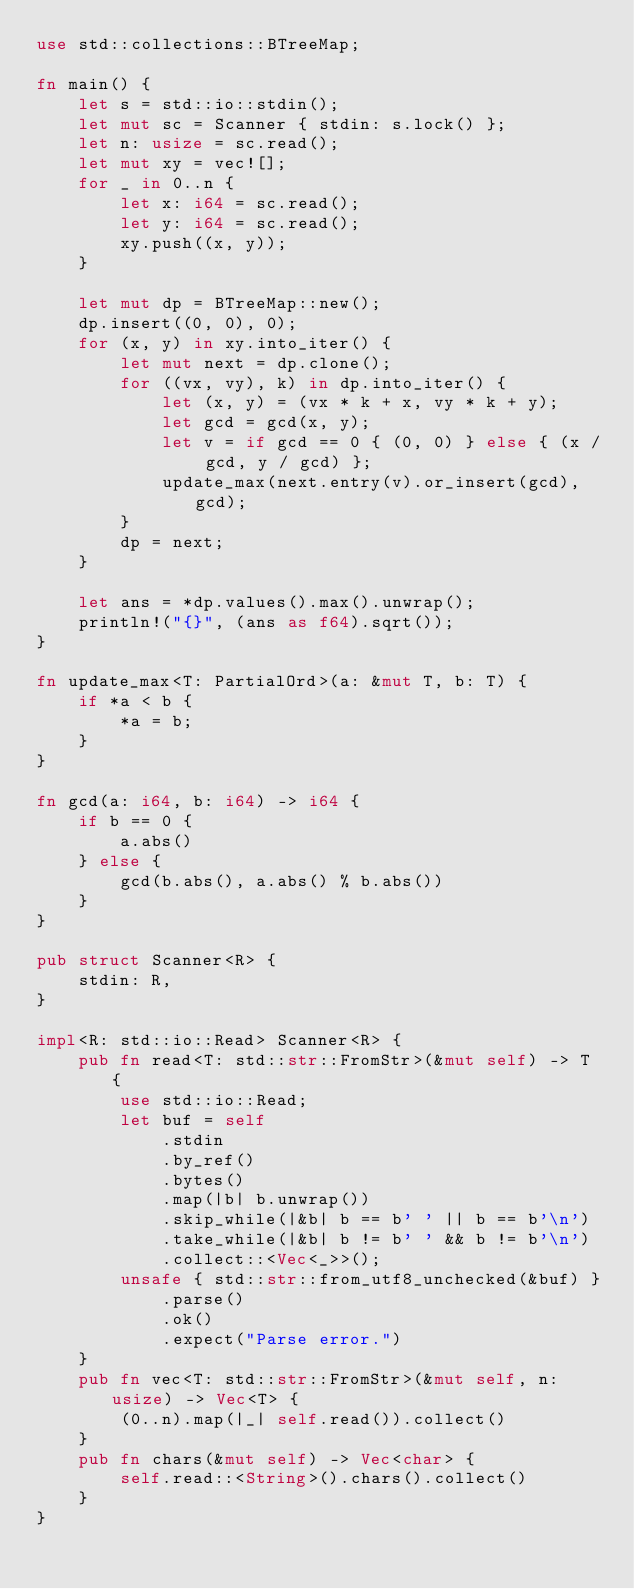Convert code to text. <code><loc_0><loc_0><loc_500><loc_500><_Rust_>use std::collections::BTreeMap;

fn main() {
    let s = std::io::stdin();
    let mut sc = Scanner { stdin: s.lock() };
    let n: usize = sc.read();
    let mut xy = vec![];
    for _ in 0..n {
        let x: i64 = sc.read();
        let y: i64 = sc.read();
        xy.push((x, y));
    }

    let mut dp = BTreeMap::new();
    dp.insert((0, 0), 0);
    for (x, y) in xy.into_iter() {
        let mut next = dp.clone();
        for ((vx, vy), k) in dp.into_iter() {
            let (x, y) = (vx * k + x, vy * k + y);
            let gcd = gcd(x, y);
            let v = if gcd == 0 { (0, 0) } else { (x / gcd, y / gcd) };
            update_max(next.entry(v).or_insert(gcd), gcd);
        }
        dp = next;
    }

    let ans = *dp.values().max().unwrap();
    println!("{}", (ans as f64).sqrt());
}

fn update_max<T: PartialOrd>(a: &mut T, b: T) {
    if *a < b {
        *a = b;
    }
}

fn gcd(a: i64, b: i64) -> i64 {
    if b == 0 {
        a.abs()
    } else {
        gcd(b.abs(), a.abs() % b.abs())
    }
}

pub struct Scanner<R> {
    stdin: R,
}

impl<R: std::io::Read> Scanner<R> {
    pub fn read<T: std::str::FromStr>(&mut self) -> T {
        use std::io::Read;
        let buf = self
            .stdin
            .by_ref()
            .bytes()
            .map(|b| b.unwrap())
            .skip_while(|&b| b == b' ' || b == b'\n')
            .take_while(|&b| b != b' ' && b != b'\n')
            .collect::<Vec<_>>();
        unsafe { std::str::from_utf8_unchecked(&buf) }
            .parse()
            .ok()
            .expect("Parse error.")
    }
    pub fn vec<T: std::str::FromStr>(&mut self, n: usize) -> Vec<T> {
        (0..n).map(|_| self.read()).collect()
    }
    pub fn chars(&mut self) -> Vec<char> {
        self.read::<String>().chars().collect()
    }
}
</code> 